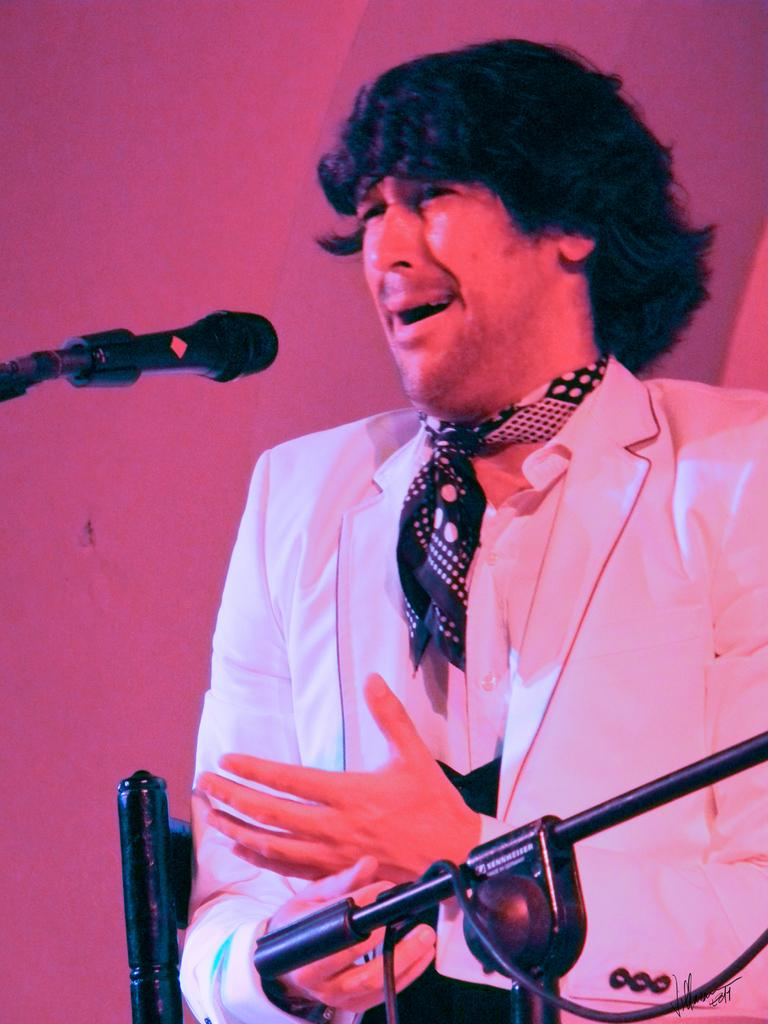What is the main subject in the foreground of the image? There is a person in the foreground of the image. What object can be seen on the left side of the image? There is a microphone on the left side of the image. What type of material is visible at the bottom of the image? Iron rods are visible at the bottom of the image. What type of line can be seen connecting the person and the microphone in the image? There is no line connecting the person and the microphone in the image. Is there a train visible in the image? No, there is no train present in the image. 